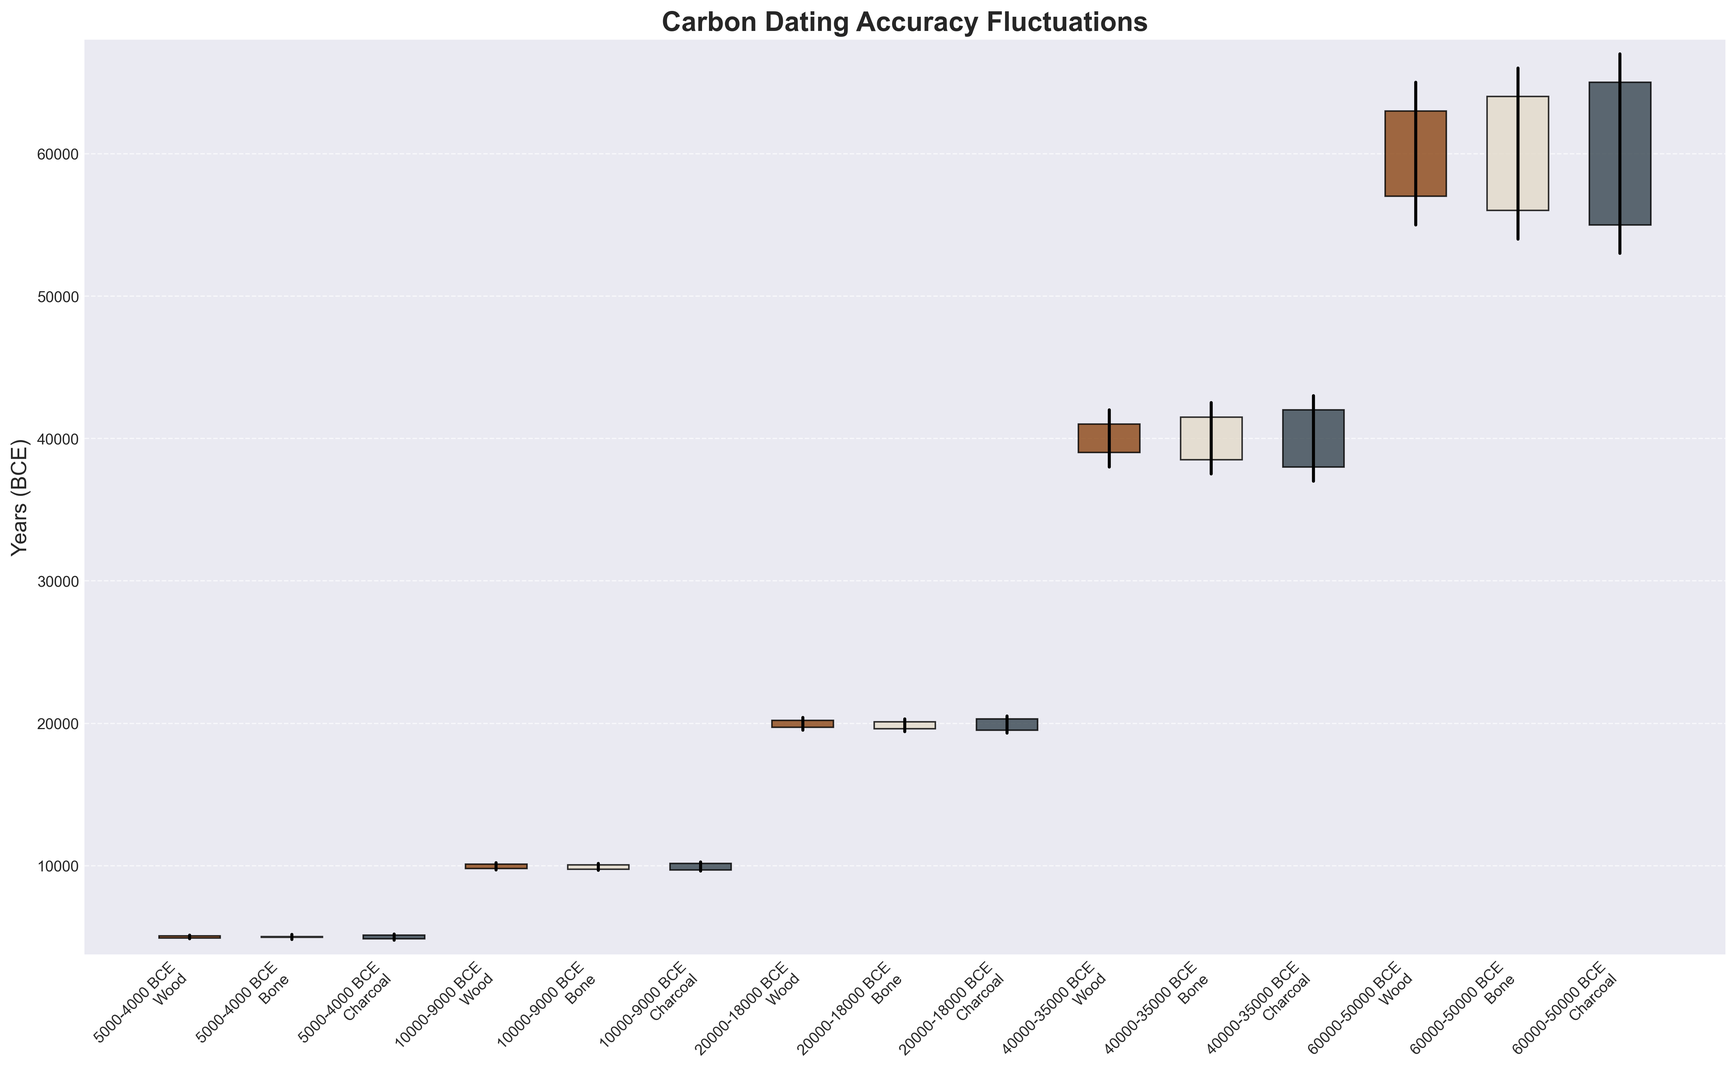What's the highest value observed in any time period for the Wood sample type? The highest value for the Wood sample type is the maximum of the 'High' values for Wood. In the time period 60000-50000 BCE, the 'High' value for Wood is 65000, which is the highest observed.
Answer: 65000 What's the average 'Close' value for Bone samples across all time periods? To find the average, sum up the 'Close' values for Bone samples and divide by the number of these samples. These values are 5000, 10050, 20100, 41500, and 64000. The average is (5000 + 10050 + 20100 + 41500 + 64000) / 5 = 28130
Answer: 28130 Which sample type shows the widest range between 'Low' and 'High' in the 40000-35000 BCE period? Calculate the range by subtracting 'Low' from 'High' for each sample type: Wood (42000 - 38000 = 4000), Bone (42500 - 37500 = 5000), Charcoal (43000 - 37000 = 6000). The widest range is for Charcoal.
Answer: Charcoal Compare the 'Low' values of all sample types in the 60000-50000 BCE period. Which has the highest 'Low' value? Check the 'Low' values in the 60000-50000 BCE period for all sample types: Wood (55000), Bone (54000), Charcoal (53000). The highest 'Low' value is for Wood.
Answer: Wood What's the median 'Open' value for the Wood sample type across all time periods? List the 'Open' values for Wood: 4900, 9800, 19700, 39000, 57000. To find the median, sort these values and locate the middle one: 4900, 9800, 19700, 39000, 57000. The median is the third value, 19700.
Answer: 19700 